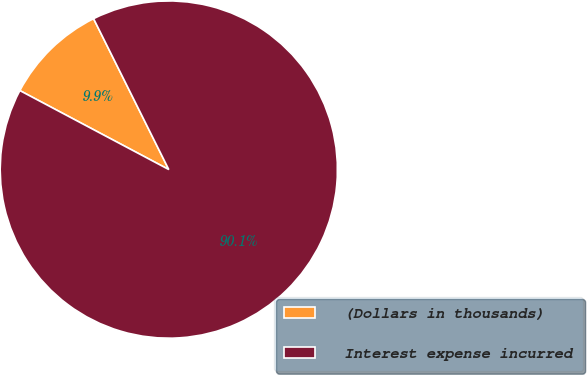<chart> <loc_0><loc_0><loc_500><loc_500><pie_chart><fcel>(Dollars in thousands)<fcel>Interest expense incurred<nl><fcel>9.88%<fcel>90.12%<nl></chart> 